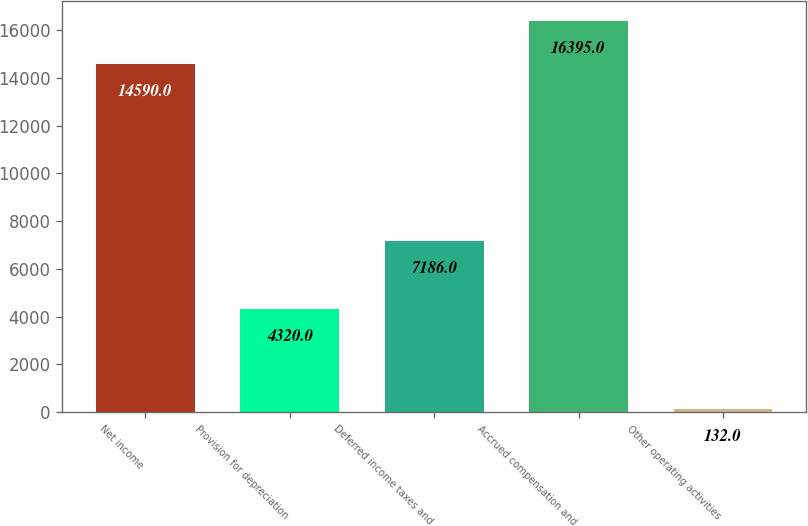Convert chart. <chart><loc_0><loc_0><loc_500><loc_500><bar_chart><fcel>Net income<fcel>Provision for depreciation<fcel>Deferred income taxes and<fcel>Accrued compensation and<fcel>Other operating activities<nl><fcel>14590<fcel>4320<fcel>7186<fcel>16395<fcel>132<nl></chart> 